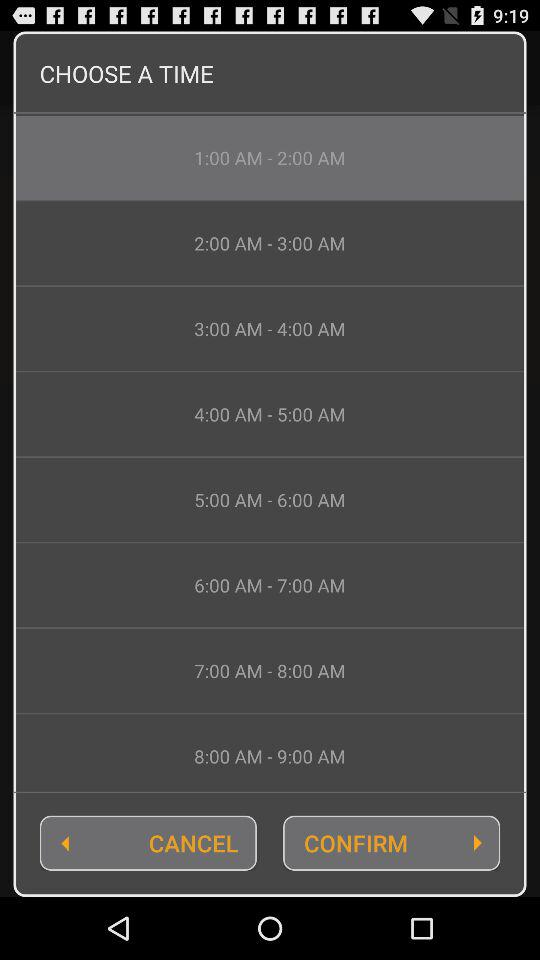How many time options are there in total?
Answer the question using a single word or phrase. 8 